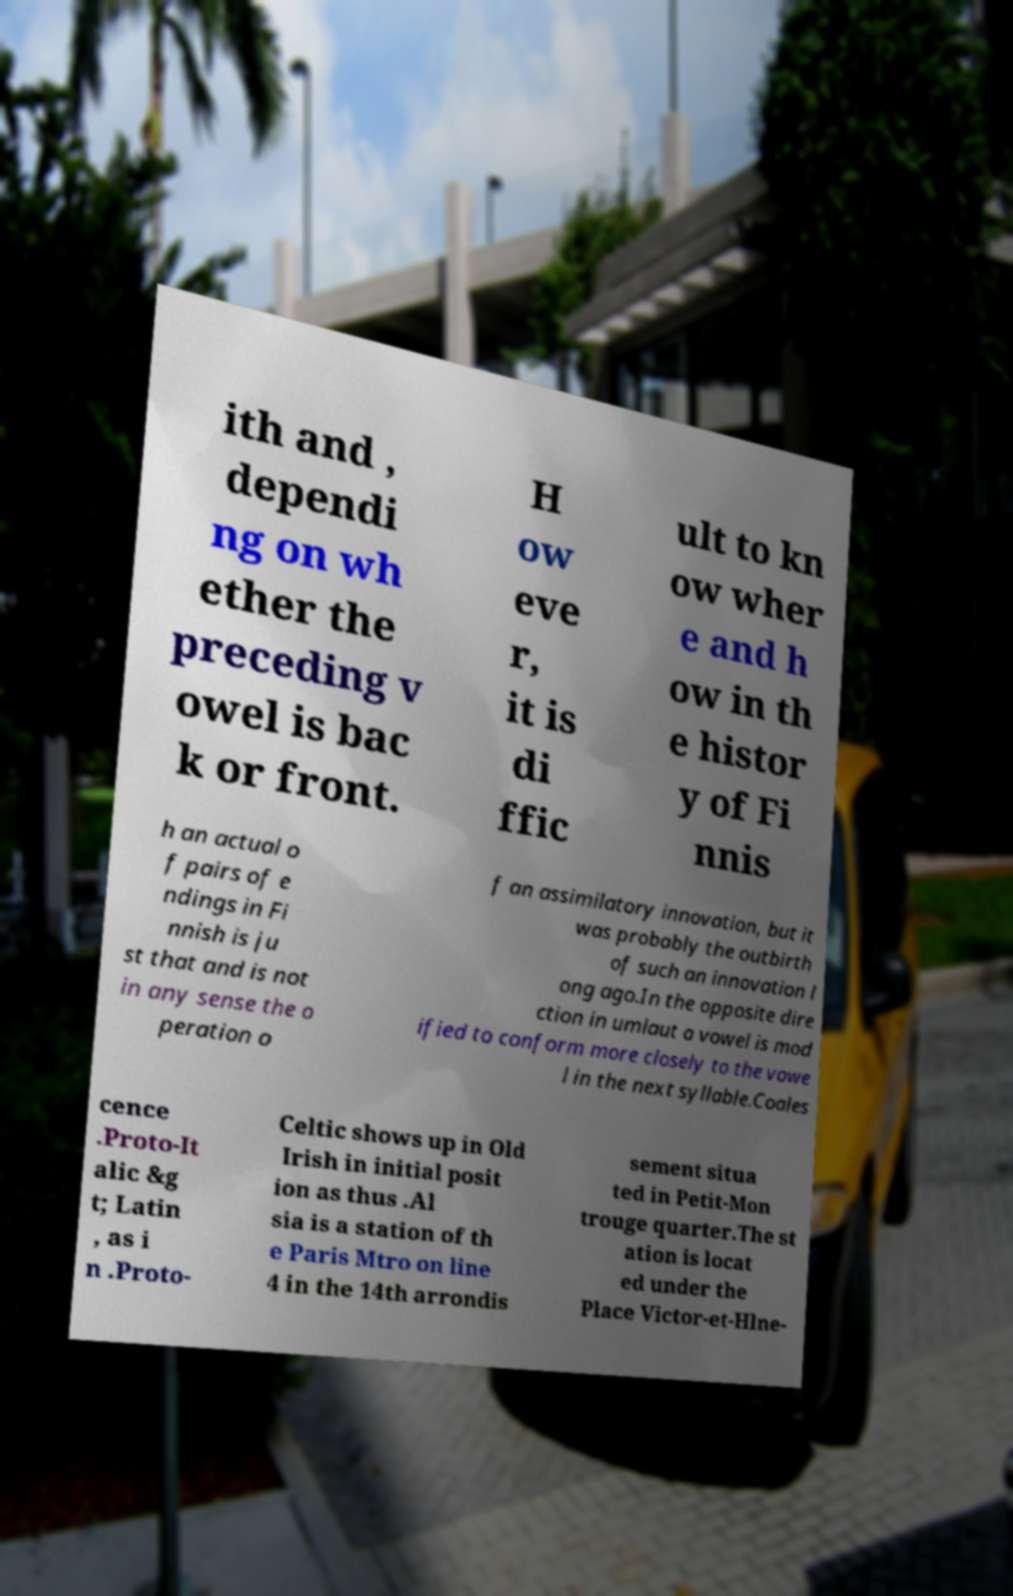Please identify and transcribe the text found in this image. ith and , dependi ng on wh ether the preceding v owel is bac k or front. H ow eve r, it is di ffic ult to kn ow wher e and h ow in th e histor y of Fi nnis h an actual o f pairs of e ndings in Fi nnish is ju st that and is not in any sense the o peration o f an assimilatory innovation, but it was probably the outbirth of such an innovation l ong ago.In the opposite dire ction in umlaut a vowel is mod ified to conform more closely to the vowe l in the next syllable.Coales cence .Proto-It alic &g t; Latin , as i n .Proto- Celtic shows up in Old Irish in initial posit ion as thus .Al sia is a station of th e Paris Mtro on line 4 in the 14th arrondis sement situa ted in Petit-Mon trouge quarter.The st ation is locat ed under the Place Victor-et-Hlne- 